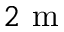Convert formula to latex. <formula><loc_0><loc_0><loc_500><loc_500>2 m</formula> 